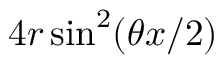<formula> <loc_0><loc_0><loc_500><loc_500>4 r \sin ^ { 2 } ( \theta x / 2 )</formula> 